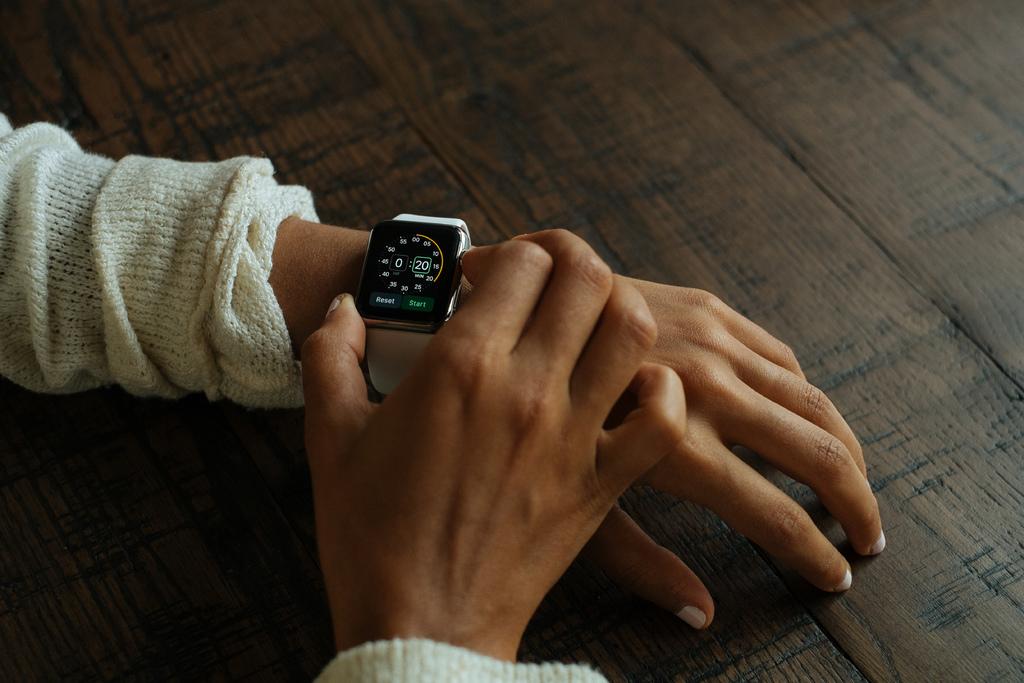What is the timer being set to?
Make the answer very short. :20. 